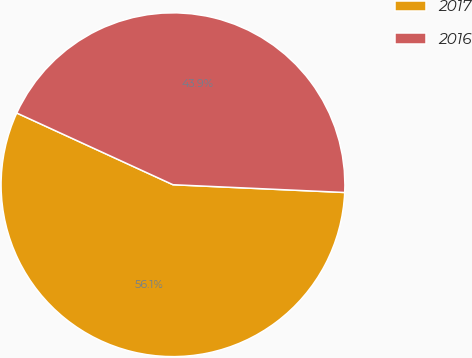Convert chart to OTSL. <chart><loc_0><loc_0><loc_500><loc_500><pie_chart><fcel>2017<fcel>2016<nl><fcel>56.13%<fcel>43.87%<nl></chart> 